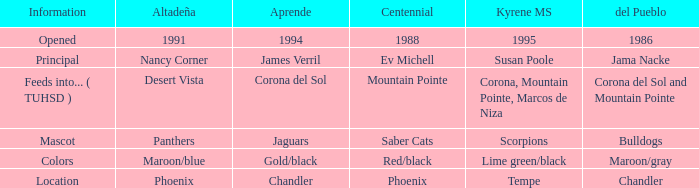Which Altadeña has a Aprende of jaguars? Panthers. 